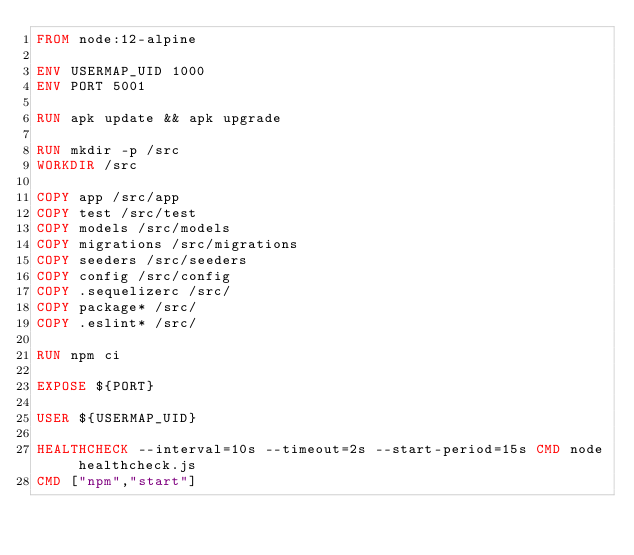Convert code to text. <code><loc_0><loc_0><loc_500><loc_500><_Dockerfile_>FROM node:12-alpine

ENV USERMAP_UID 1000
ENV PORT 5001

RUN apk update && apk upgrade

RUN mkdir -p /src
WORKDIR /src

COPY app /src/app
COPY test /src/test
COPY models /src/models
COPY migrations /src/migrations
COPY seeders /src/seeders
COPY config /src/config
COPY .sequelizerc /src/
COPY package* /src/
COPY .eslint* /src/

RUN npm ci

EXPOSE ${PORT}

USER ${USERMAP_UID}

HEALTHCHECK --interval=10s --timeout=2s --start-period=15s CMD node healthcheck.js
CMD ["npm","start"]
</code> 